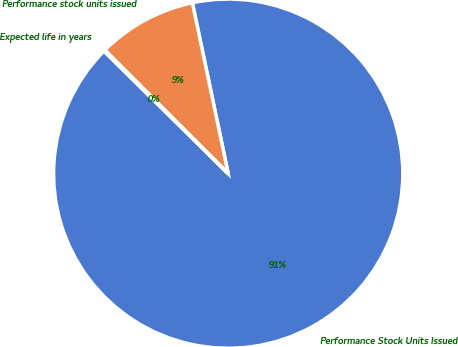Convert chart to OTSL. <chart><loc_0><loc_0><loc_500><loc_500><pie_chart><fcel>Performance Stock Units Issued<fcel>Performance stock units issued<fcel>Expected life in years<nl><fcel>90.68%<fcel>9.19%<fcel>0.13%<nl></chart> 